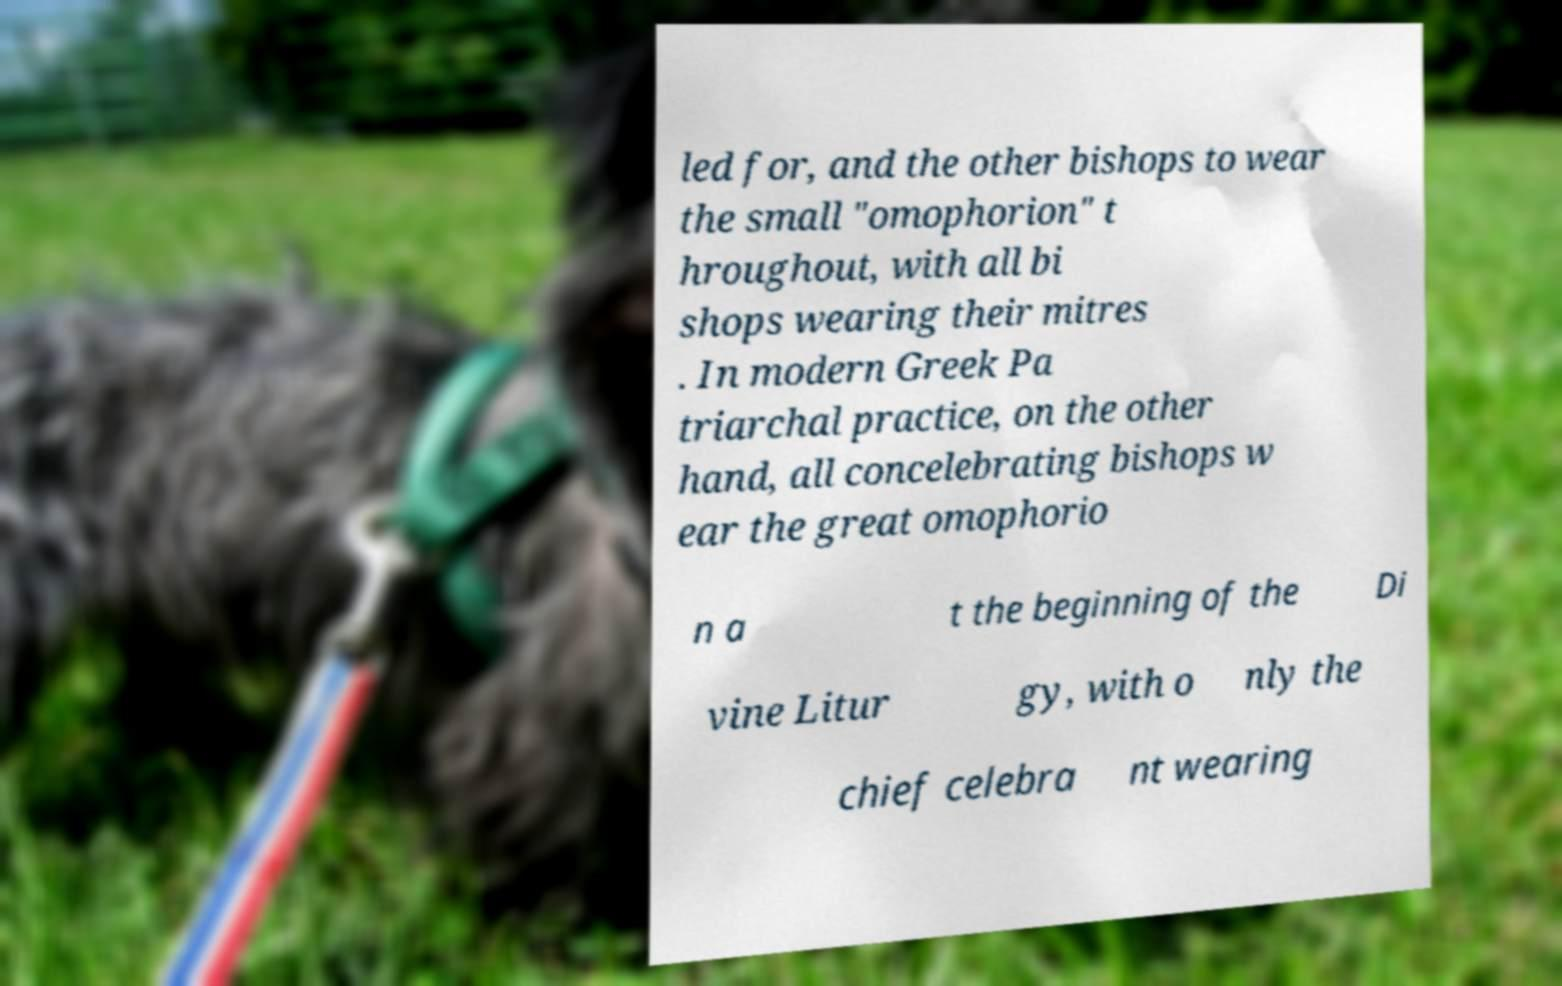Please identify and transcribe the text found in this image. led for, and the other bishops to wear the small "omophorion" t hroughout, with all bi shops wearing their mitres . In modern Greek Pa triarchal practice, on the other hand, all concelebrating bishops w ear the great omophorio n a t the beginning of the Di vine Litur gy, with o nly the chief celebra nt wearing 